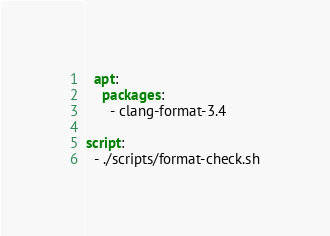<code> <loc_0><loc_0><loc_500><loc_500><_YAML_>  apt:
    packages:
      - clang-format-3.4

script:
  - ./scripts/format-check.sh
</code> 